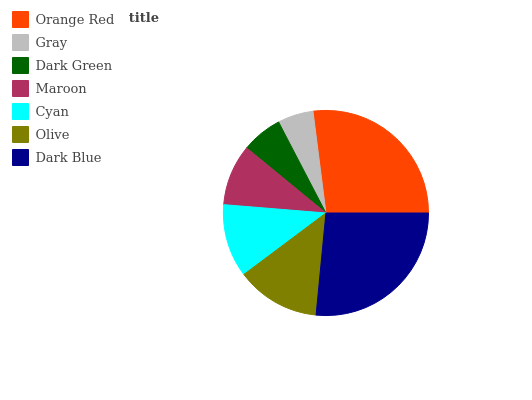Is Gray the minimum?
Answer yes or no. Yes. Is Orange Red the maximum?
Answer yes or no. Yes. Is Dark Green the minimum?
Answer yes or no. No. Is Dark Green the maximum?
Answer yes or no. No. Is Dark Green greater than Gray?
Answer yes or no. Yes. Is Gray less than Dark Green?
Answer yes or no. Yes. Is Gray greater than Dark Green?
Answer yes or no. No. Is Dark Green less than Gray?
Answer yes or no. No. Is Cyan the high median?
Answer yes or no. Yes. Is Cyan the low median?
Answer yes or no. Yes. Is Maroon the high median?
Answer yes or no. No. Is Maroon the low median?
Answer yes or no. No. 